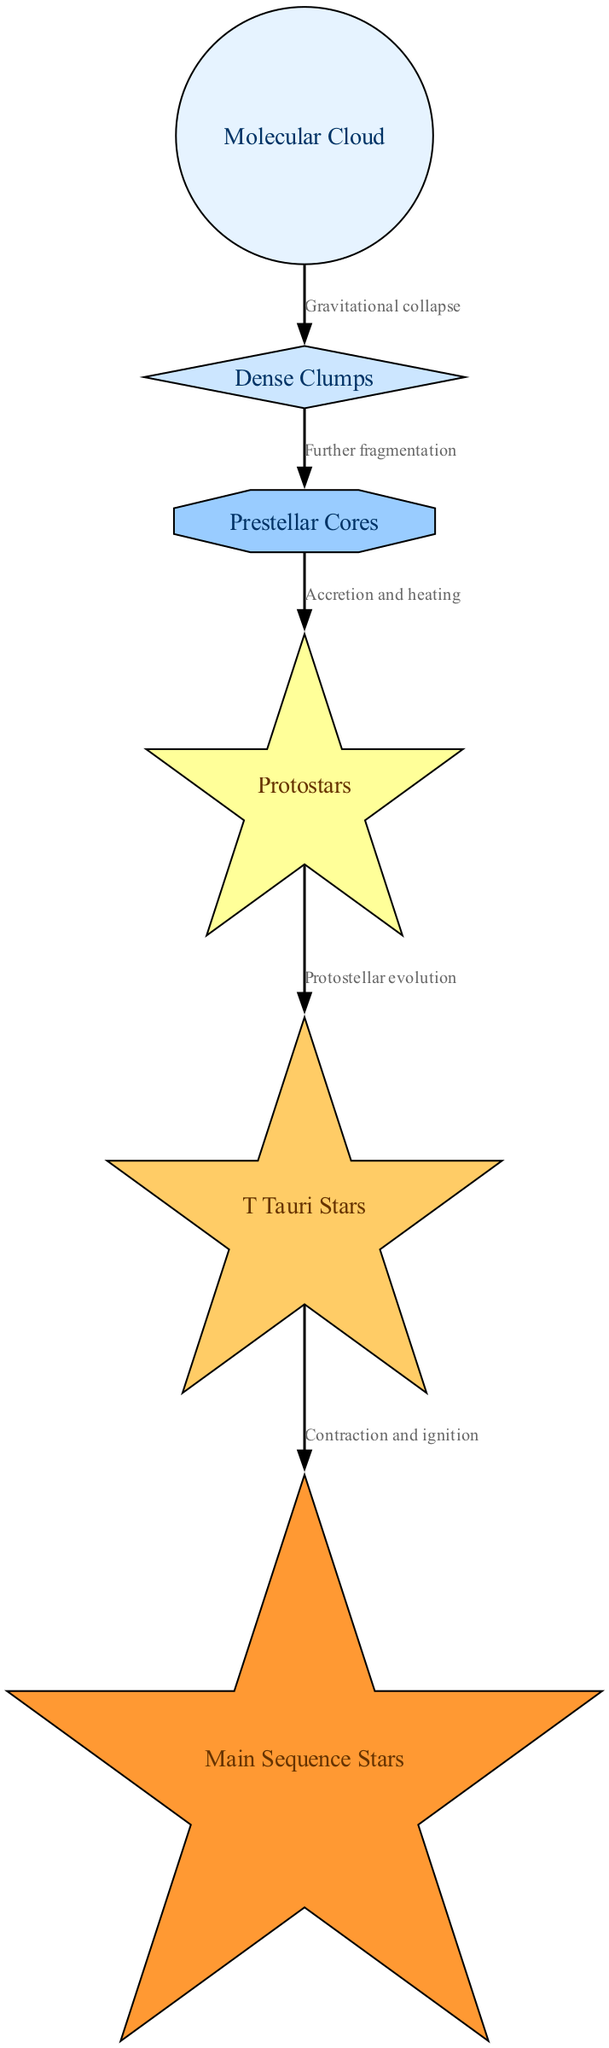What is the first step in the star formation sequence? The diagram begins with the "Molecular Cloud," which is the starting point for the star formation sequence. It is the initial node before any other steps occur in the progression.
Answer: Molecular Cloud How many nodes are present in the diagram? By counting all distinct entities represented in the diagram, we find there are six nodes, including "Molecular Cloud," "Dense Clumps," "Prestellar Cores," "Protostars," "T Tauri Stars," and "Main Sequence Stars."
Answer: Six What relationship leads from "Prestellar Cores" to "Protostars"? The diagram indicates that the connection from "Prestellar Cores" to "Protostars" is defined by "Accretion and heating," which describes the process involved in the transition to the next stage of star formation.
Answer: Accretion and heating Which type of star follows "T Tauri Stars"? Examining the flow in the diagram, the next progression after "T Tauri Stars" is to "Main Sequence Stars," showcasing the sequential evolution that stars undergo in their lifecycle.
Answer: Main Sequence Stars How are "Dense Clumps" formed from "Molecular Cloud"? The transition from "Molecular Cloud" to "Dense Clumps" is due to "Gravitational collapse," which highlights the physical process that leads to the fragmentation of the molecular cloud into denser regions.
Answer: Gravitational collapse What is shown at the end of the star formation sequence? The last entity in the diagram is "Main Sequence Stars," which indicates the culmination of the star formation process in this specific sequence, representing a stable phase in stellar evolution.
Answer: Main Sequence Stars What signifies the transition from "Protostars" to "T Tauri Stars"? The flow from "Protostars" to "T Tauri Stars" is indicated by "Protostellar evolution," marking a significant phase change as protostars mature and evolve into T Tauri stars.
Answer: Protostellar evolution Which node has a shape of a diamond? The node labeled "Dense Clumps" is uniquely represented as a diamond in the diagram, differentiating it from other nodes that have different shapes assigned to them, according to the visual style used.
Answer: Dense Clumps How many edges are there in the diagram? Counting the specified connections between the nodes in the diagram reveals that there are five edges supporting the relationships laid out between the various stages in the star formation sequence.
Answer: Five 